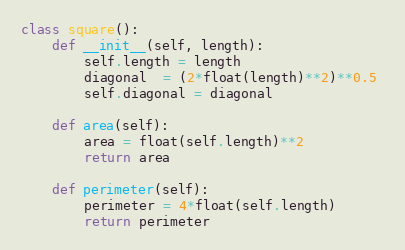<code> <loc_0><loc_0><loc_500><loc_500><_Python_>class square():
    def __init__(self, length):
        self.length = length
        diagonal  = (2*float(length)**2)**0.5 
        self.diagonal = diagonal
    
    def area(self):
        area = float(self.length)**2
        return area

    def perimeter(self):
        perimeter = 4*float(self.length)
        return perimeter</code> 